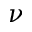Convert formula to latex. <formula><loc_0><loc_0><loc_500><loc_500>\nu</formula> 